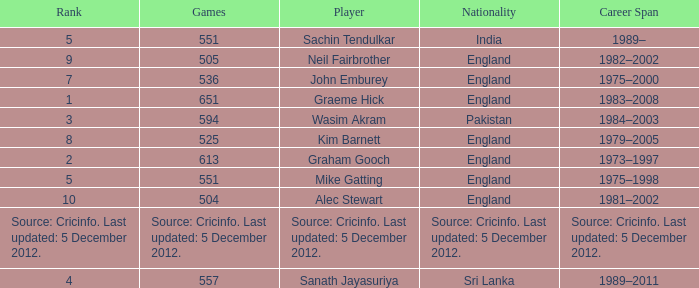What is the country of origin for the player who took part in 505 games? England. 